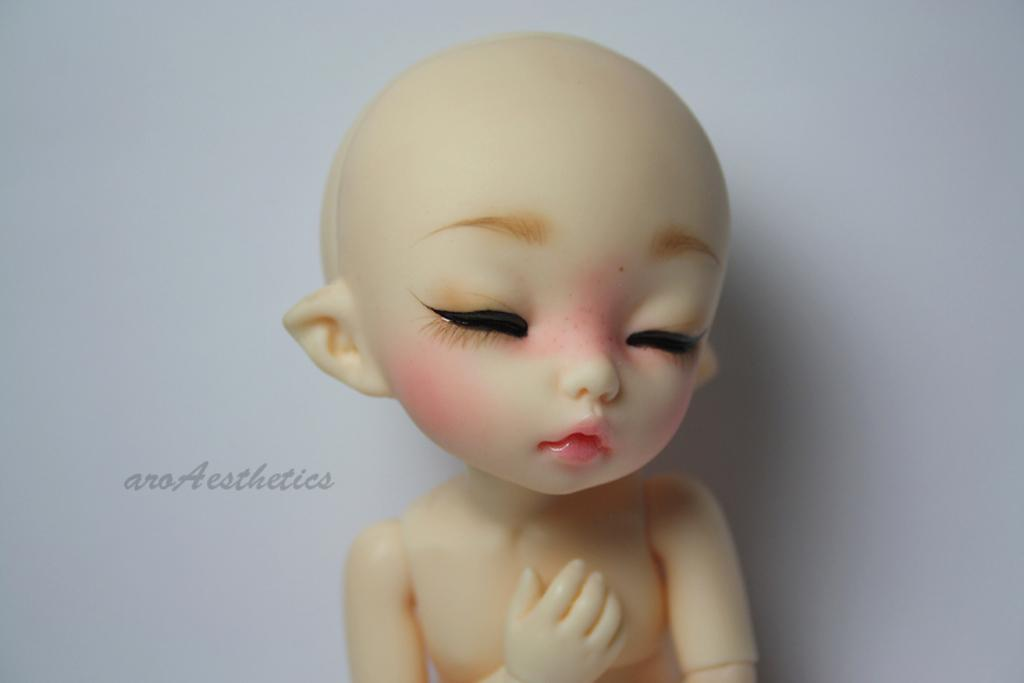What object can be seen in the image? There is a toy in the image. What can be seen in the background of the image? There is a wall in the background of the image. What type of quartz can be seen in the image? There is no quartz present in the image; it features a toy and a wall in the background. What is the taste of the toy in the image? Toys do not have a taste, as they are inanimate objects. 